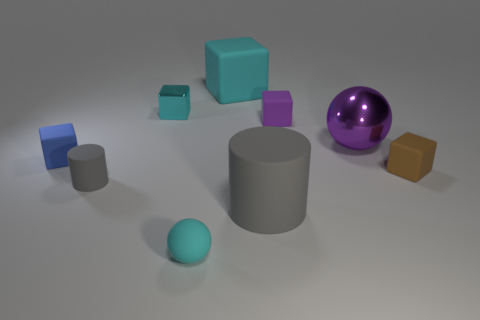If these objects were part of a still life painting, what mood would they convey? If these objects were in a still life painting, they might convey a mood of calm and order due to their neat arrangement and the balance of shapes and colors. The cool color palette of blues and purples, along with the soft lighting, would contribute to a serene and contemplative atmosphere in the artwork. 